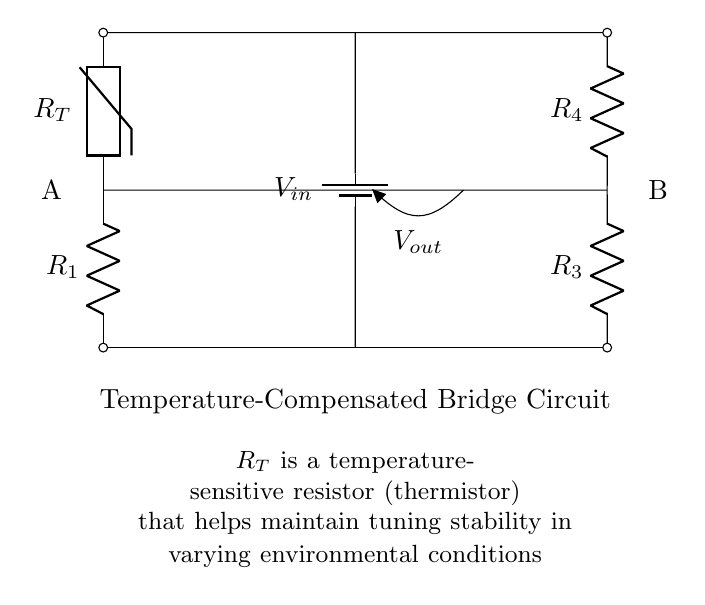What type of resistor is used in this circuit? The circuit contains a thermistor, which is a type of resistor that varies its resistance with temperature.
Answer: thermistor What are the two resistors on the left side of the bridge labeled? The left side has a resistor labeled R1 connected in series with a thermistor.
Answer: R1 and thermistor How is the voltage supplied in this circuit? The circuit has a battery providing input voltage from the top to the bottom, creating a potential difference.
Answer: battery What is the output voltage taken from? The output voltage is measured at the junction between the resistors on the right side and the center of the bridge.
Answer: Vout Explain the purpose of the thermistor in the circuit. The thermistor is used to stabilize tuning in response to temperature changes, ensuring that the bridge remains balanced despite environmental variations.
Answer: Maintain tuning stability Which component helps maintain tuning stability? The components that adjust resistance with temperature, specifically the thermistor, maintain the tuning stability of the bridge.
Answer: thermistor What type of circuit is this? This is a temperature-compensated bridge circuit designed for tuning stability in varying conditions.
Answer: bridge circuit 